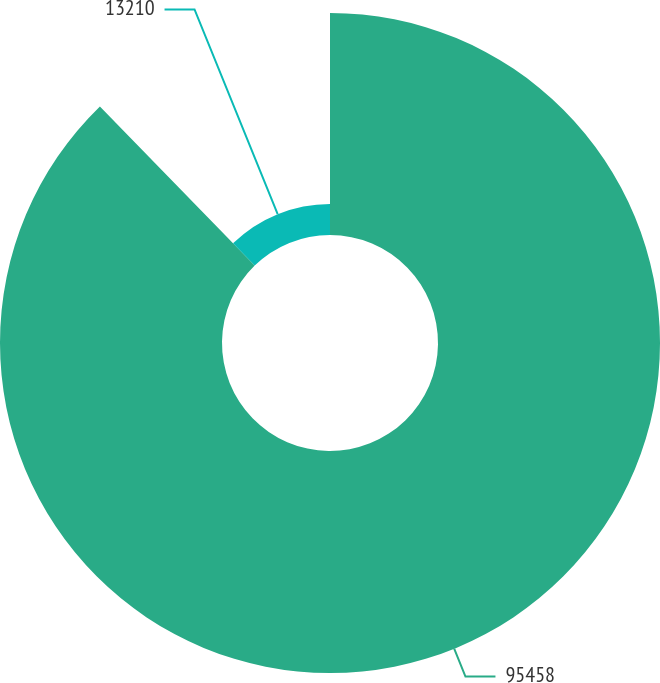Convert chart. <chart><loc_0><loc_0><loc_500><loc_500><pie_chart><fcel>95458<fcel>13210<nl><fcel>87.72%<fcel>12.28%<nl></chart> 